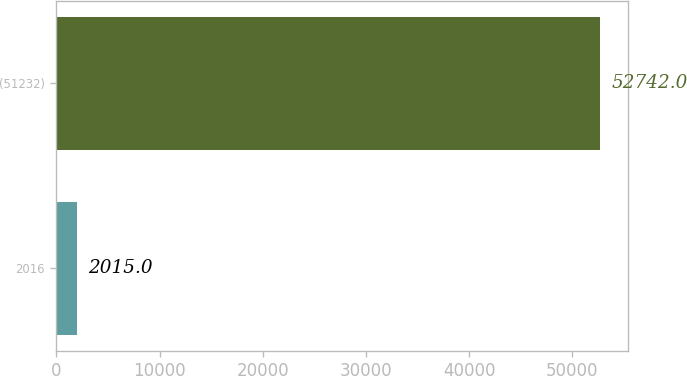Convert chart to OTSL. <chart><loc_0><loc_0><loc_500><loc_500><bar_chart><fcel>2016<fcel>(51232)<nl><fcel>2015<fcel>52742<nl></chart> 